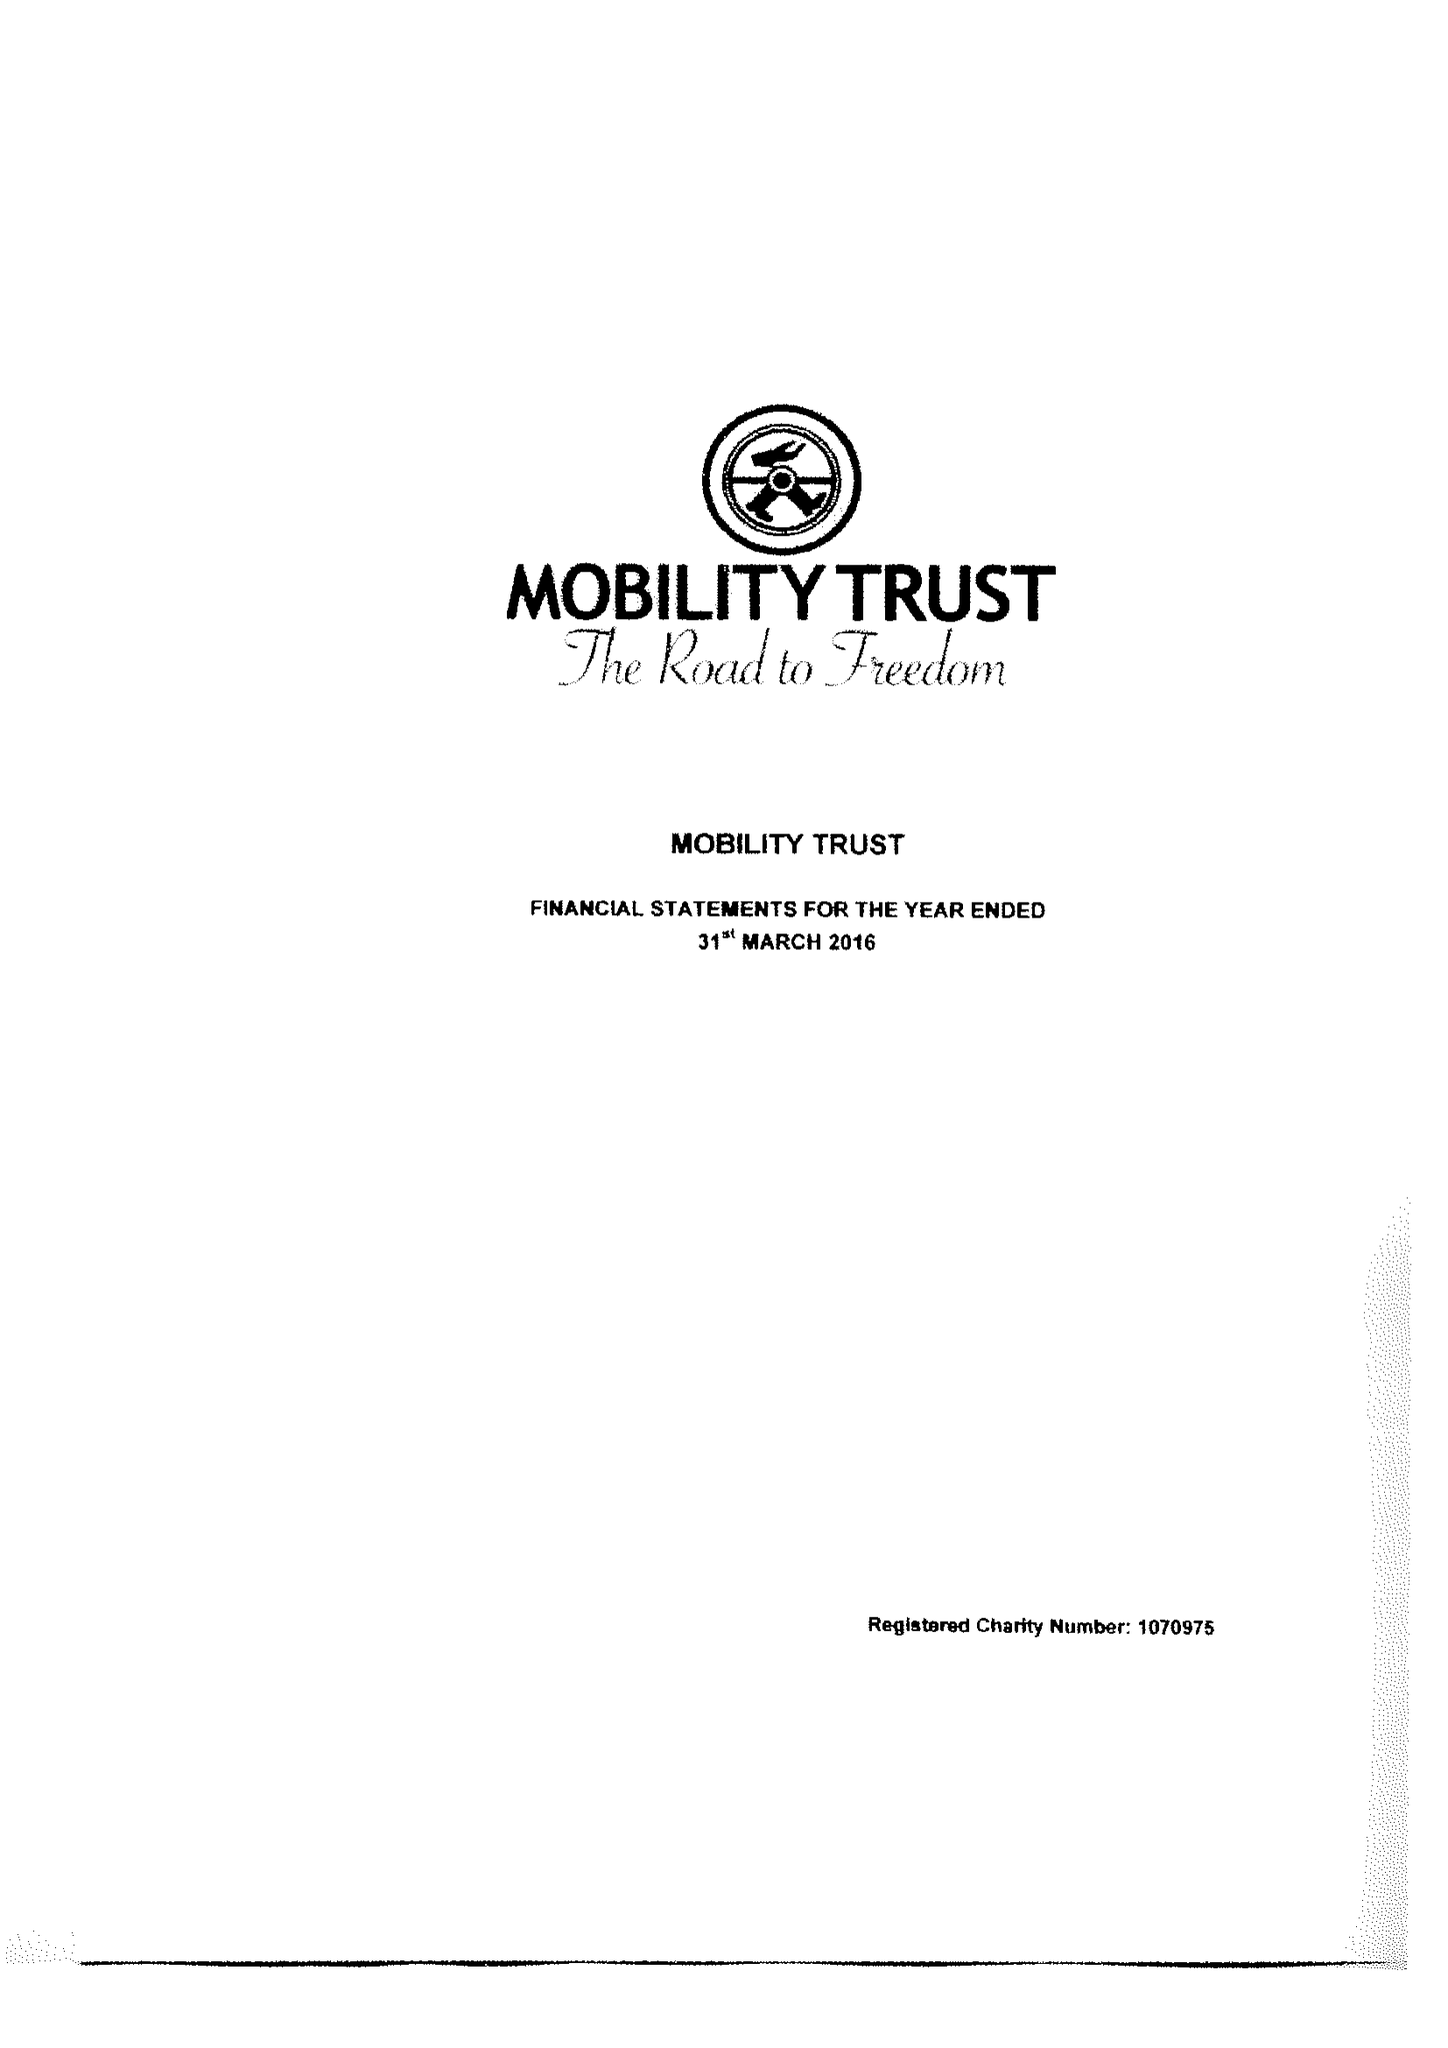What is the value for the charity_number?
Answer the question using a single word or phrase. 1070975 